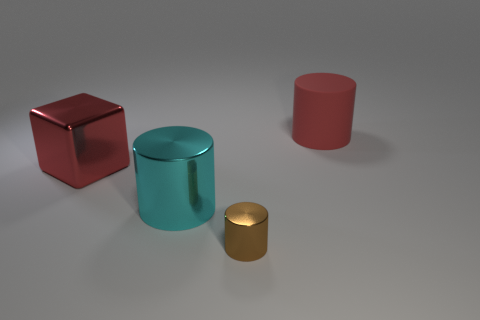There is another cyan thing that is the same shape as the matte thing; what is its size?
Give a very brief answer. Large. Is the big red block made of the same material as the thing to the right of the small brown metallic object?
Your answer should be compact. No. There is a cylinder that is behind the red metal object; what is its color?
Keep it short and to the point. Red. What number of other objects are the same color as the big matte object?
Give a very brief answer. 1. There is a thing behind the red metal thing; does it have the same size as the big cyan cylinder?
Your response must be concise. Yes. What number of large red rubber things are left of the big cyan thing?
Provide a short and direct response. 0. Are there any cyan shiny objects that have the same size as the brown shiny cylinder?
Offer a terse response. No. Do the metal block and the big rubber cylinder have the same color?
Your response must be concise. Yes. There is a cylinder behind the big red thing that is left of the small brown cylinder; what color is it?
Your response must be concise. Red. How many large cylinders are in front of the cube and on the right side of the big cyan metallic thing?
Your answer should be very brief. 0. 